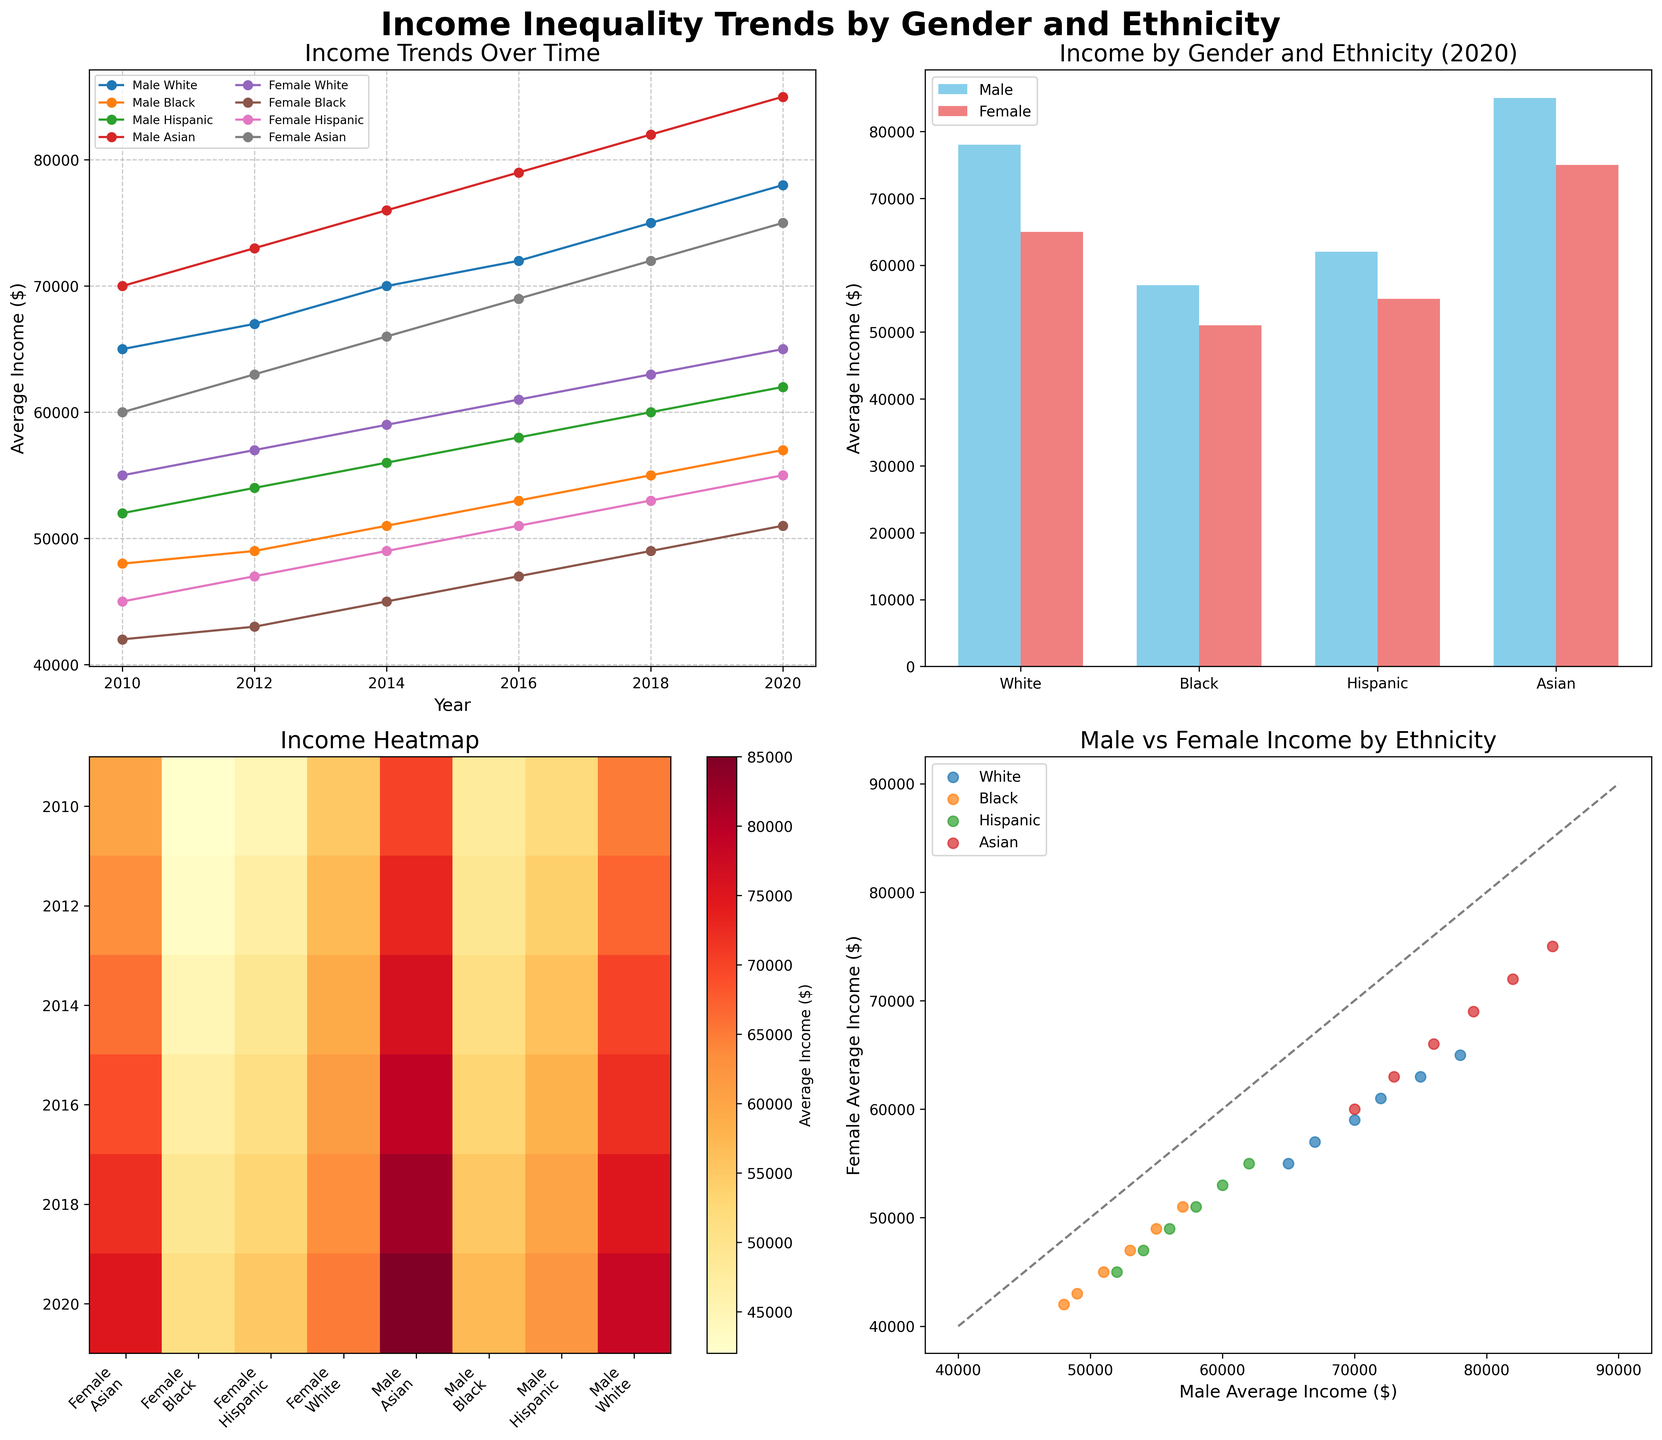what is the average income of White males in 2020? To find the average income of White males in 2020, look at the data points for 2020 under the "Male" gender and "White" ethnicity. The average income reported is 78000.
Answer: 78000 which gender had a higher average income among Asian ethnicity in 2018? To determine which gender had a higher average income among the Asian ethnicity in 2018, compare the income values for males and females in the data for 2018. The values are 82000 for males and 72000 for females, so males had a higher average income.
Answer: Male what is the overall trend for the average income of Black females from 2010 to 2020? To observe the trend, look at the data points for average income of Black females from 2010 to 2020. The values are 42000 (2010), 43000 (2012), 45000 (2014), 47000 (2016), 49000 (2018), and 51000 (2020). It shows a consistent increase over time.
Answer: Increasing compare the average income between Hispanic males and Hispanic females in 2020, and determine the difference First, find the average income for Hispanic males and females in 2020. The values are 62000 for males and 55000 for females. The difference between them is 62000 - 55000 = 7000.
Answer: 7000 which ethnicity had the smallest gender income disparity in 2020? To find the ethnicity with the smallest gender income disparity in 2020, calculate the absolute difference between the average incomes of males and females for each ethnicity: White (78000 - 65000 = 13000), Black (57000 - 51000 = 6000), Hispanic (62000 - 55000 = 7000), Asian (85000 - 75000 = 10000). The smallest disparity is for the Black ethnicity with a disparity of 6000.
Answer: Black Based on the heatmap, which year shows the highest average income for Asian males In the heatmap subplot, locate the row for Asian males and find the cell with the highest value. The highest average income for Asian males appears in 2020.
Answer: 2020 how does the income trend for Hispanic females compare to that of Black males over the years? To compare the trends, look at the line plots for Hispanic females and Black males from 2010 to 2020: Hispanic females (45000, 47000, 49000, 51000, 53000, 55000) and Black males (48000, 49000, 51000, 53000, 55000, 57000). Both groups show a consistent increase, with Black males having slightly higher incomes and similar growth rates.
Answer: Similar trends, Black males slightly higher Does the scatter plot suggest any strong correlation between male and female incomes by ethnicity? The scatter plot shows male and female incomes by ethnicity. If the points lie close to the equality line (y = x), it suggests a strong positive correlation. Observing the points, they are near the line, indicating a strong correlation between male and female incomes by ethnicity.
Answer: Strong correlation How much did the average income for White males increase from 2010 to 2020? To find the increase in average income for White males from 2010 to 2020, subtract the 2010 income from the 2020 income: 78000 - 65000 = 13000.
Answer: 13000 what does the bar graph indicate about the income gap between males and females in Asian ethnicity for 2020? In the bar graph, compare the male and female bars for Asian ethnicity in 2020. The heights of the bars for males and females show values 85000 and 75000, respectively. The gap between the two values is 10000, indicating males earned more.
Answer: 10000 